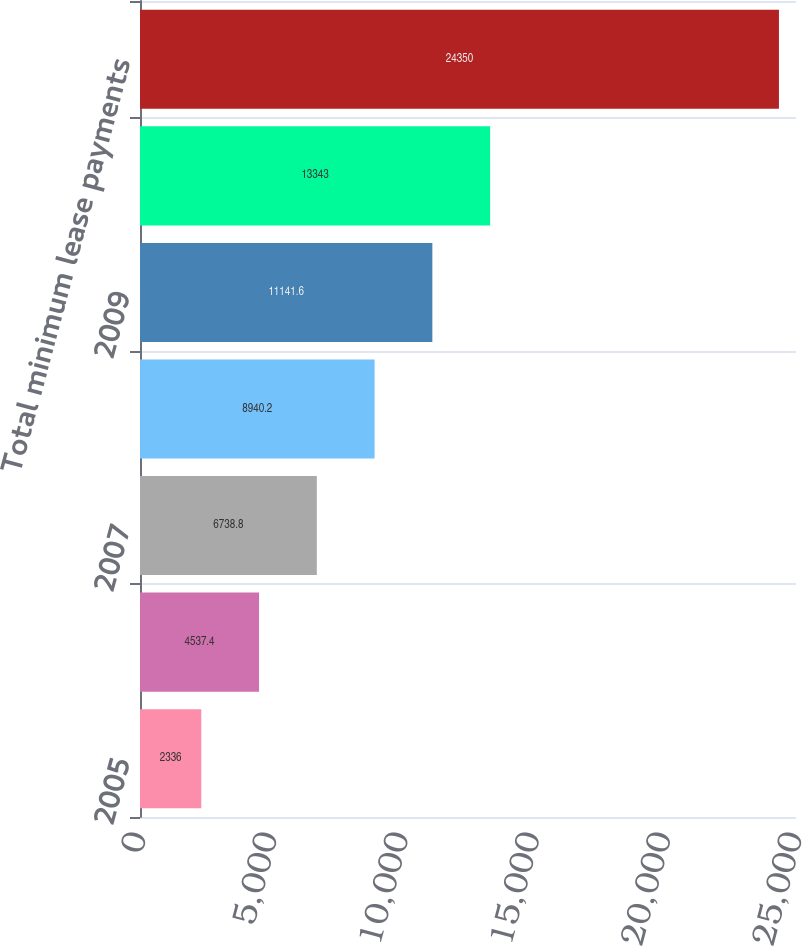Convert chart. <chart><loc_0><loc_0><loc_500><loc_500><bar_chart><fcel>2005<fcel>2006<fcel>2007<fcel>2008<fcel>2009<fcel>Thereafter<fcel>Total minimum lease payments<nl><fcel>2336<fcel>4537.4<fcel>6738.8<fcel>8940.2<fcel>11141.6<fcel>13343<fcel>24350<nl></chart> 